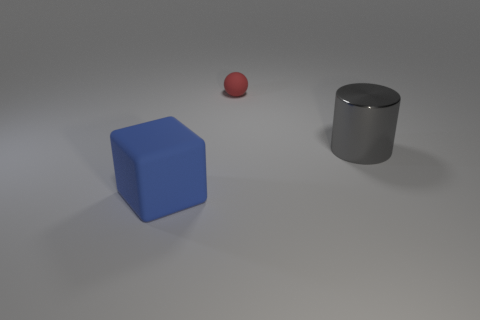The object that is both to the left of the large gray cylinder and to the right of the big blue thing is what color? The object you are referring to appears to be a small red sphere. Its position to the left of the large gray cylinder and to the right of the big blue cube makes it stand out with its distinct red hue. 